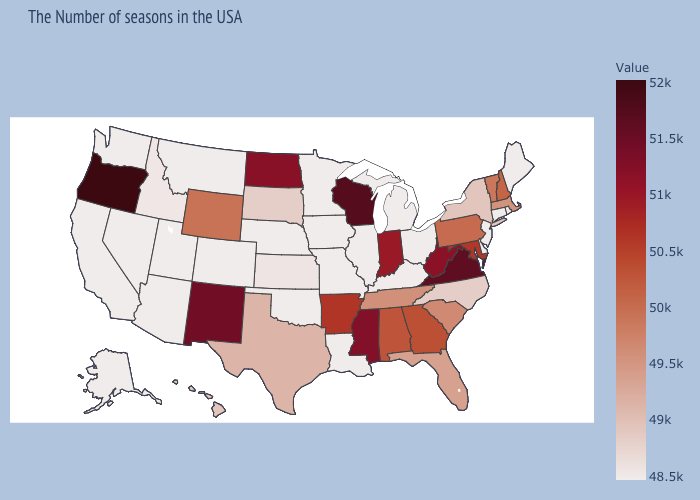Does Arizona have a higher value than New Hampshire?
Quick response, please. No. Does Virginia have a lower value than New Jersey?
Write a very short answer. No. Does South Dakota have a higher value than West Virginia?
Give a very brief answer. No. Which states have the lowest value in the USA?
Short answer required. Maine, Rhode Island, Connecticut, New Jersey, Delaware, Ohio, Michigan, Illinois, Louisiana, Missouri, Minnesota, Iowa, Nebraska, Oklahoma, Colorado, Utah, Montana, Arizona, Nevada, California, Washington, Alaska. Does Alabama have the lowest value in the South?
Answer briefly. No. Does Hawaii have the lowest value in the USA?
Answer briefly. No. Does New Mexico have a higher value than Oregon?
Write a very short answer. No. 